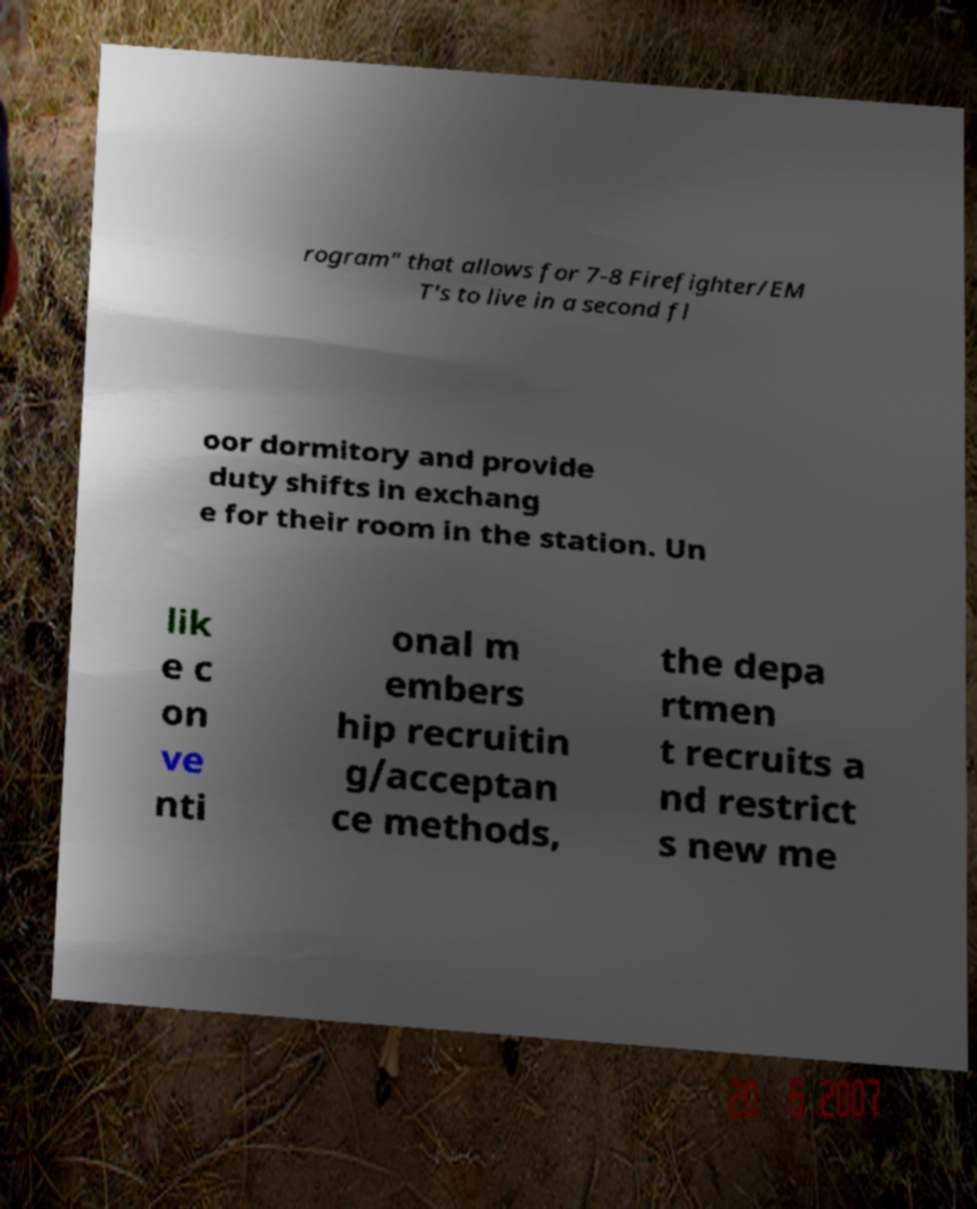For documentation purposes, I need the text within this image transcribed. Could you provide that? rogram" that allows for 7-8 Firefighter/EM T's to live in a second fl oor dormitory and provide duty shifts in exchang e for their room in the station. Un lik e c on ve nti onal m embers hip recruitin g/acceptan ce methods, the depa rtmen t recruits a nd restrict s new me 